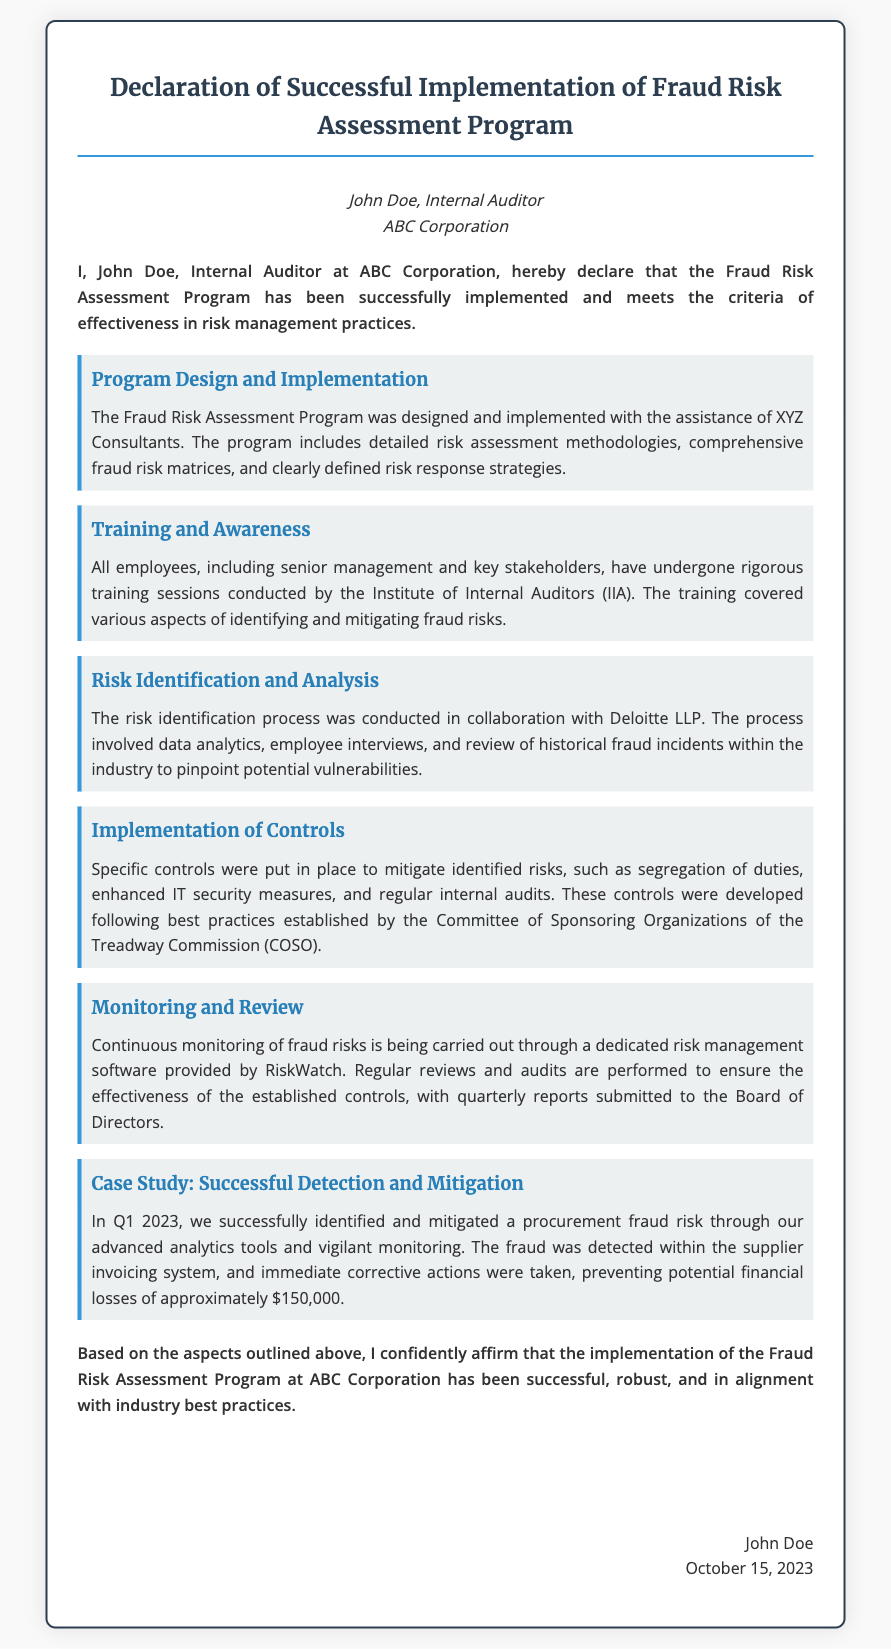what is the name of the internal auditor? The internal auditor’s name is provided at the beginning of the document.
Answer: John Doe what is the date of the declaration? The date of the declaration is mentioned in the signature section at the bottom of the document.
Answer: October 15, 2023 who assisted in the design and implementation of the Fraud Risk Assessment Program? The name of the consulting organization involved is mentioned in the details about program design.
Answer: XYZ Consultants what was the potential financial loss prevented due to the successful mitigation of fraud? The document includes a specific dollar amount related to the detection of procurement fraud risk.
Answer: $150,000 which organization provided training sessions on fraud risk? The document specifies the organization responsible for conducting the training sessions for employees.
Answer: Institute of Internal Auditors (IIA) what is the title of the document? The title of the declaration is explicitly stated at the top of the document.
Answer: Declaration of Successful Implementation of Fraud Risk Assessment Program which software is used for monitoring fraud risks? The document names the software tool utilized for continuous monitoring of fraud risks.
Answer: RiskWatch what best practices were followed for developing controls? The document mentions a specific organization recognized for establishing best practices in control development.
Answer: Committee of Sponsoring Organizations of the Treadway Commission (COSO) what was the focus of the risk identification process? The document details various aspects involved in the risk identification process, emphasizing its comprehensive nature.
Answer: Data analytics, employee interviews, and review of historical fraud incidents 